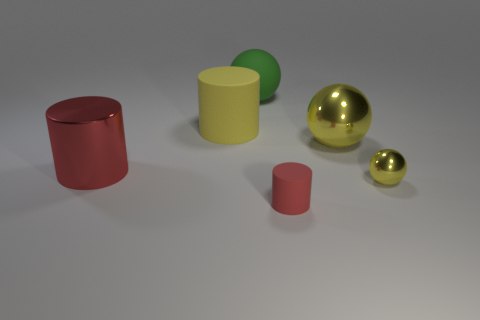Subtract all metal spheres. How many spheres are left? 1 Subtract all yellow spheres. How many spheres are left? 1 Add 2 large balls. How many objects exist? 8 Subtract all small metallic spheres. Subtract all metal balls. How many objects are left? 3 Add 6 red matte cylinders. How many red matte cylinders are left? 7 Add 5 big red metal cylinders. How many big red metal cylinders exist? 6 Subtract 1 yellow cylinders. How many objects are left? 5 Subtract 1 spheres. How many spheres are left? 2 Subtract all cyan spheres. Subtract all gray cylinders. How many spheres are left? 3 Subtract all brown cylinders. How many green spheres are left? 1 